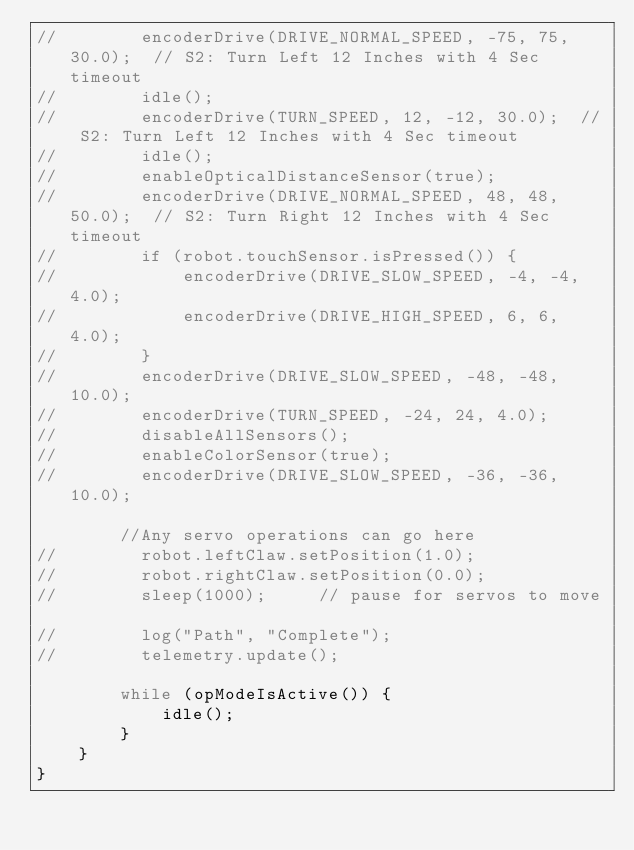Convert code to text. <code><loc_0><loc_0><loc_500><loc_500><_Java_>//        encoderDrive(DRIVE_NORMAL_SPEED, -75, 75, 30.0);  // S2: Turn Left 12 Inches with 4 Sec timeout
//        idle();
//        encoderDrive(TURN_SPEED, 12, -12, 30.0);  // S2: Turn Left 12 Inches with 4 Sec timeout
//        idle();
//        enableOpticalDistanceSensor(true);
//        encoderDrive(DRIVE_NORMAL_SPEED, 48, 48, 50.0);  // S2: Turn Right 12 Inches with 4 Sec timeout
//        if (robot.touchSensor.isPressed()) {
//            encoderDrive(DRIVE_SLOW_SPEED, -4, -4, 4.0);
//            encoderDrive(DRIVE_HIGH_SPEED, 6, 6, 4.0);
//        }
//        encoderDrive(DRIVE_SLOW_SPEED, -48, -48, 10.0);
//        encoderDrive(TURN_SPEED, -24, 24, 4.0);
//        disableAllSensors();
//        enableColorSensor(true);
//        encoderDrive(DRIVE_SLOW_SPEED, -36, -36, 10.0);

        //Any servo operations can go here
//        robot.leftClaw.setPosition(1.0);
//        robot.rightClaw.setPosition(0.0);
//        sleep(1000);     // pause for servos to move

//        log("Path", "Complete");
//        telemetry.update();

        while (opModeIsActive()) {
            idle();
        }
    }
}
</code> 